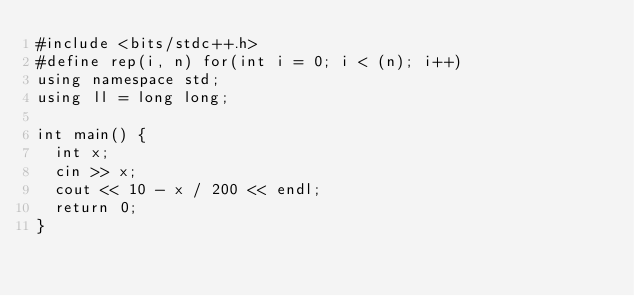<code> <loc_0><loc_0><loc_500><loc_500><_C++_>#include <bits/stdc++.h>
#define rep(i, n) for(int i = 0; i < (n); i++)
using namespace std;
using ll = long long;

int main() {
	int x;
	cin >> x;
	cout << 10 - x / 200 << endl;
	return 0;
}</code> 